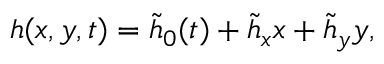Convert formula to latex. <formula><loc_0><loc_0><loc_500><loc_500>{ h } ( x , y , t ) = \tilde { h } _ { 0 } ( t ) + \tilde { h } _ { x } x + \tilde { h } _ { y } y ,</formula> 